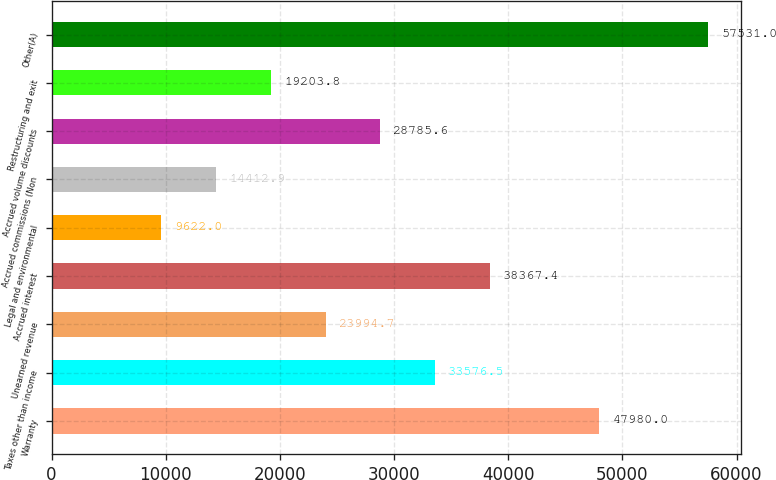Convert chart. <chart><loc_0><loc_0><loc_500><loc_500><bar_chart><fcel>Warranty<fcel>Taxes other than income<fcel>Unearned revenue<fcel>Accrued interest<fcel>Legal and environmental<fcel>Accrued commissions (Non<fcel>Accrued volume discounts<fcel>Restructuring and exit<fcel>Other(A)<nl><fcel>47980<fcel>33576.5<fcel>23994.7<fcel>38367.4<fcel>9622<fcel>14412.9<fcel>28785.6<fcel>19203.8<fcel>57531<nl></chart> 